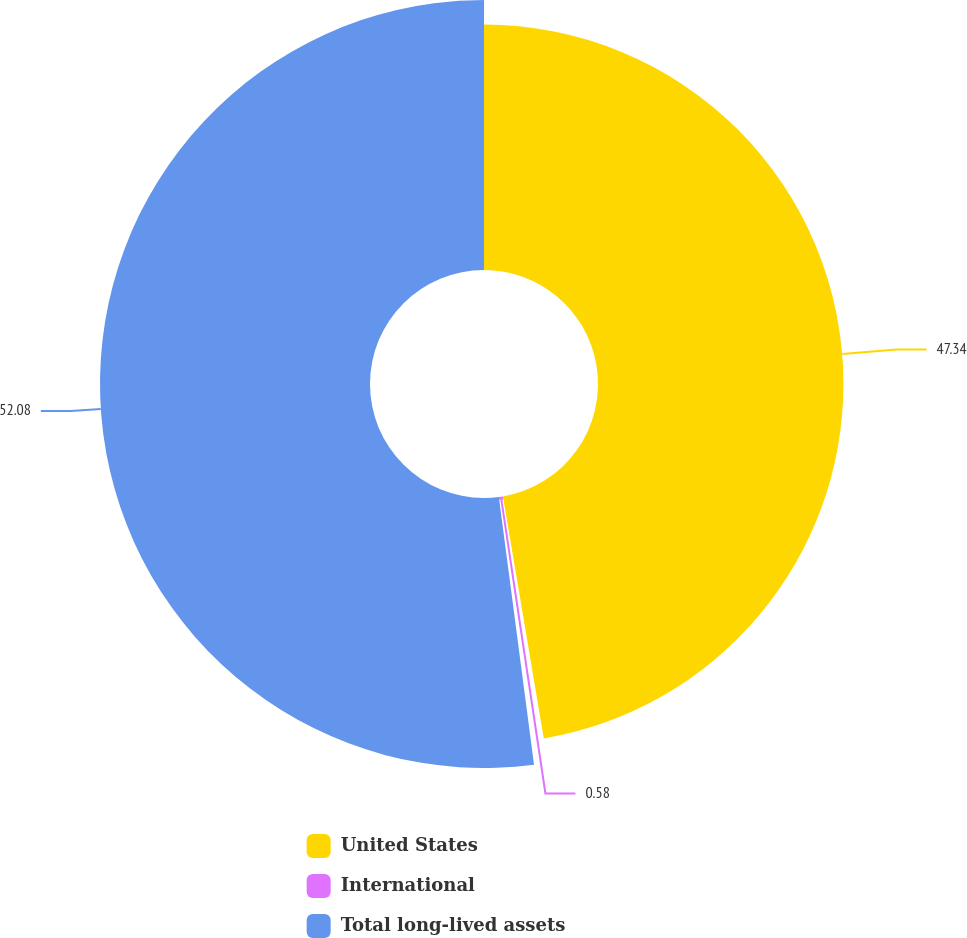<chart> <loc_0><loc_0><loc_500><loc_500><pie_chart><fcel>United States<fcel>International<fcel>Total long-lived assets<nl><fcel>47.34%<fcel>0.58%<fcel>52.08%<nl></chart> 